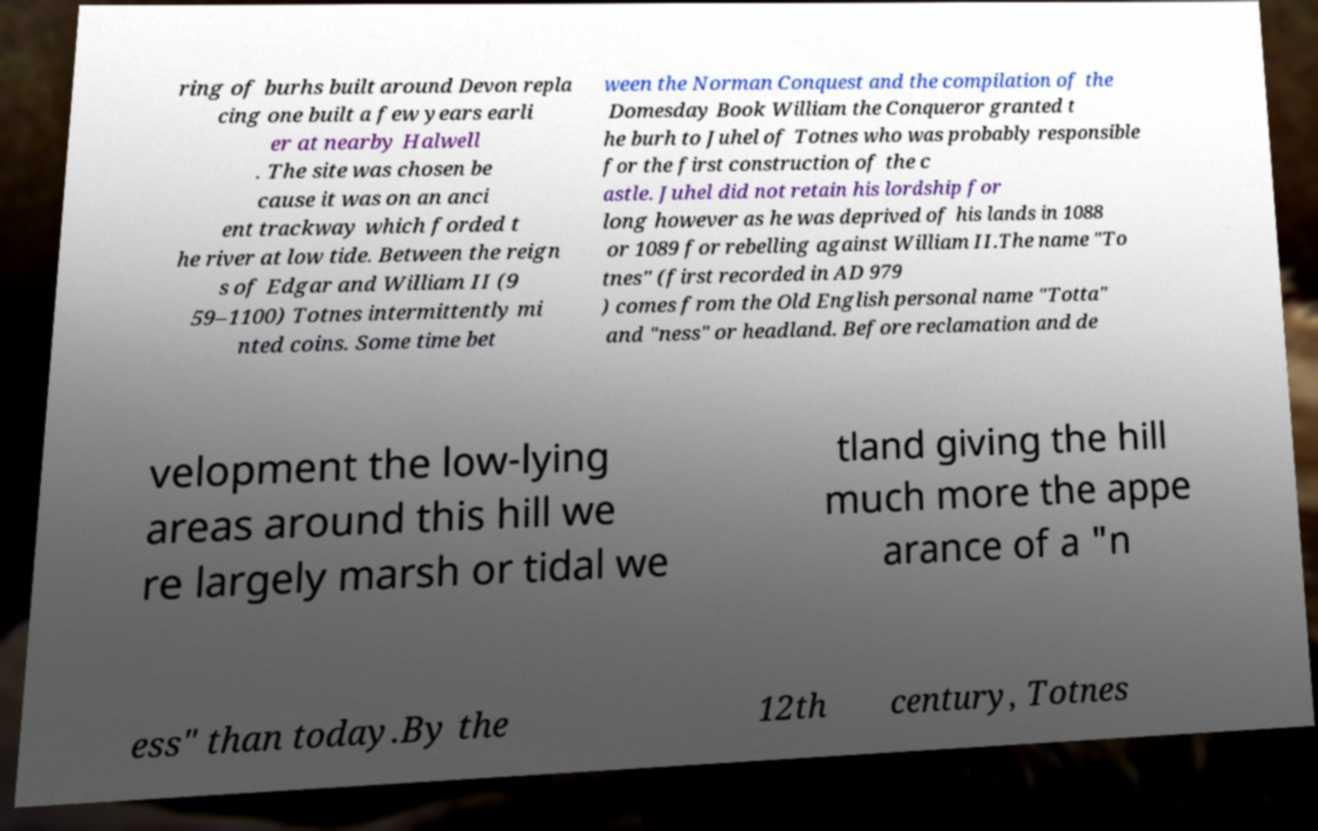Please identify and transcribe the text found in this image. ring of burhs built around Devon repla cing one built a few years earli er at nearby Halwell . The site was chosen be cause it was on an anci ent trackway which forded t he river at low tide. Between the reign s of Edgar and William II (9 59–1100) Totnes intermittently mi nted coins. Some time bet ween the Norman Conquest and the compilation of the Domesday Book William the Conqueror granted t he burh to Juhel of Totnes who was probably responsible for the first construction of the c astle. Juhel did not retain his lordship for long however as he was deprived of his lands in 1088 or 1089 for rebelling against William II.The name "To tnes" (first recorded in AD 979 ) comes from the Old English personal name "Totta" and "ness" or headland. Before reclamation and de velopment the low-lying areas around this hill we re largely marsh or tidal we tland giving the hill much more the appe arance of a "n ess" than today.By the 12th century, Totnes 